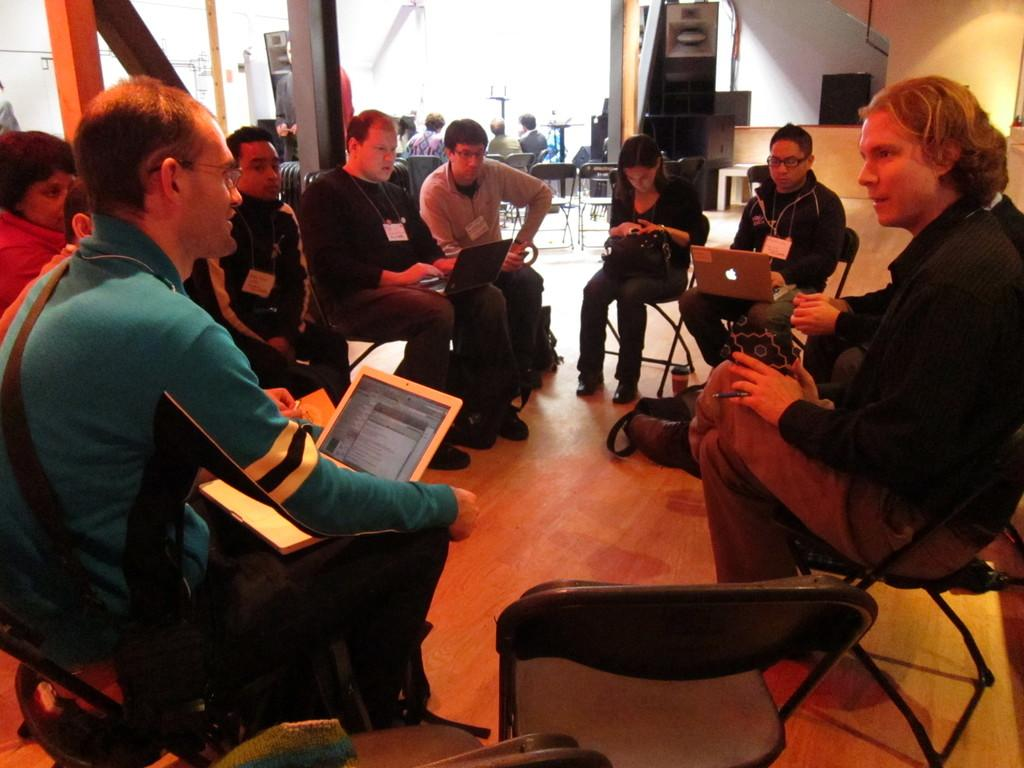What are the people in the image doing? There is a group of people sitting in the image. What objects can be seen with the people in the image? There are laptops visible in the image. What can be seen in the background of the image? In the background of the image, there are people sitting, and there are pillars visible. What type of tooth is being used to open the laptop in the image? There is no tooth present in the image, and no one is using a tooth to open a laptop. 